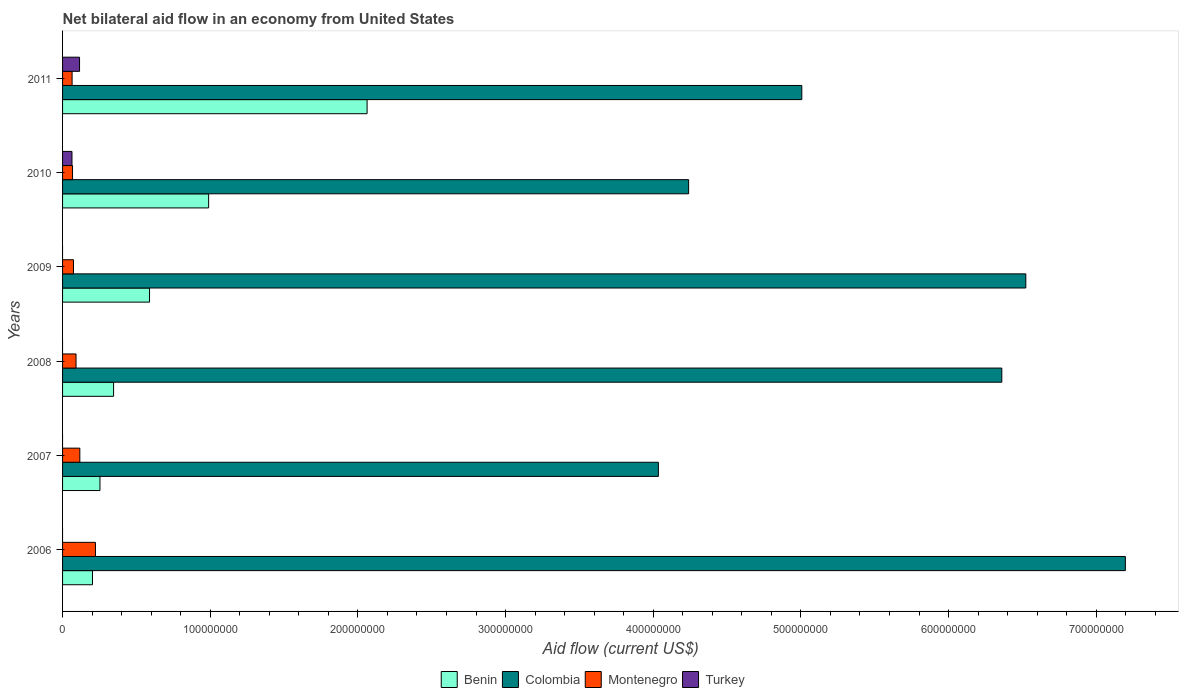How many different coloured bars are there?
Your answer should be very brief. 4. How many groups of bars are there?
Offer a terse response. 6. Are the number of bars on each tick of the Y-axis equal?
Your answer should be compact. No. How many bars are there on the 5th tick from the top?
Make the answer very short. 3. How many bars are there on the 4th tick from the bottom?
Ensure brevity in your answer.  3. What is the net bilateral aid flow in Montenegro in 2009?
Your answer should be compact. 7.38e+06. Across all years, what is the maximum net bilateral aid flow in Colombia?
Keep it short and to the point. 7.20e+08. Across all years, what is the minimum net bilateral aid flow in Turkey?
Your answer should be compact. 0. In which year was the net bilateral aid flow in Turkey maximum?
Your answer should be compact. 2011. What is the total net bilateral aid flow in Benin in the graph?
Your response must be concise. 4.44e+08. What is the difference between the net bilateral aid flow in Montenegro in 2009 and that in 2010?
Offer a very short reply. 6.30e+05. What is the difference between the net bilateral aid flow in Benin in 2009 and the net bilateral aid flow in Colombia in 2011?
Ensure brevity in your answer.  -4.42e+08. What is the average net bilateral aid flow in Turkey per year?
Ensure brevity in your answer.  2.98e+06. In the year 2008, what is the difference between the net bilateral aid flow in Benin and net bilateral aid flow in Colombia?
Your answer should be very brief. -6.02e+08. What is the ratio of the net bilateral aid flow in Montenegro in 2007 to that in 2010?
Make the answer very short. 1.73. What is the difference between the highest and the second highest net bilateral aid flow in Colombia?
Your answer should be very brief. 6.74e+07. What is the difference between the highest and the lowest net bilateral aid flow in Turkey?
Offer a terse response. 1.15e+07. How many bars are there?
Your response must be concise. 20. How many years are there in the graph?
Keep it short and to the point. 6. What is the difference between two consecutive major ticks on the X-axis?
Offer a very short reply. 1.00e+08. Does the graph contain any zero values?
Your answer should be compact. Yes. Where does the legend appear in the graph?
Offer a terse response. Bottom center. How many legend labels are there?
Keep it short and to the point. 4. What is the title of the graph?
Provide a short and direct response. Net bilateral aid flow in an economy from United States. Does "Sri Lanka" appear as one of the legend labels in the graph?
Make the answer very short. No. What is the label or title of the Y-axis?
Your response must be concise. Years. What is the Aid flow (current US$) of Benin in 2006?
Ensure brevity in your answer.  2.03e+07. What is the Aid flow (current US$) of Colombia in 2006?
Ensure brevity in your answer.  7.20e+08. What is the Aid flow (current US$) in Montenegro in 2006?
Offer a very short reply. 2.23e+07. What is the Aid flow (current US$) of Benin in 2007?
Ensure brevity in your answer.  2.53e+07. What is the Aid flow (current US$) of Colombia in 2007?
Your answer should be compact. 4.04e+08. What is the Aid flow (current US$) in Montenegro in 2007?
Ensure brevity in your answer.  1.17e+07. What is the Aid flow (current US$) in Turkey in 2007?
Your response must be concise. 0. What is the Aid flow (current US$) of Benin in 2008?
Ensure brevity in your answer.  3.46e+07. What is the Aid flow (current US$) of Colombia in 2008?
Offer a very short reply. 6.36e+08. What is the Aid flow (current US$) in Montenegro in 2008?
Your response must be concise. 9.12e+06. What is the Aid flow (current US$) of Turkey in 2008?
Give a very brief answer. 0. What is the Aid flow (current US$) in Benin in 2009?
Ensure brevity in your answer.  5.89e+07. What is the Aid flow (current US$) in Colombia in 2009?
Your answer should be very brief. 6.52e+08. What is the Aid flow (current US$) of Montenegro in 2009?
Offer a terse response. 7.38e+06. What is the Aid flow (current US$) of Benin in 2010?
Keep it short and to the point. 9.89e+07. What is the Aid flow (current US$) of Colombia in 2010?
Ensure brevity in your answer.  4.24e+08. What is the Aid flow (current US$) in Montenegro in 2010?
Provide a succinct answer. 6.75e+06. What is the Aid flow (current US$) of Turkey in 2010?
Offer a very short reply. 6.38e+06. What is the Aid flow (current US$) in Benin in 2011?
Provide a short and direct response. 2.06e+08. What is the Aid flow (current US$) in Colombia in 2011?
Offer a very short reply. 5.01e+08. What is the Aid flow (current US$) of Montenegro in 2011?
Make the answer very short. 6.45e+06. What is the Aid flow (current US$) of Turkey in 2011?
Offer a terse response. 1.15e+07. Across all years, what is the maximum Aid flow (current US$) in Benin?
Provide a short and direct response. 2.06e+08. Across all years, what is the maximum Aid flow (current US$) of Colombia?
Provide a short and direct response. 7.20e+08. Across all years, what is the maximum Aid flow (current US$) in Montenegro?
Your response must be concise. 2.23e+07. Across all years, what is the maximum Aid flow (current US$) in Turkey?
Your answer should be compact. 1.15e+07. Across all years, what is the minimum Aid flow (current US$) in Benin?
Provide a short and direct response. 2.03e+07. Across all years, what is the minimum Aid flow (current US$) of Colombia?
Your answer should be very brief. 4.04e+08. Across all years, what is the minimum Aid flow (current US$) in Montenegro?
Keep it short and to the point. 6.45e+06. Across all years, what is the minimum Aid flow (current US$) of Turkey?
Give a very brief answer. 0. What is the total Aid flow (current US$) in Benin in the graph?
Give a very brief answer. 4.44e+08. What is the total Aid flow (current US$) of Colombia in the graph?
Provide a succinct answer. 3.34e+09. What is the total Aid flow (current US$) in Montenegro in the graph?
Provide a succinct answer. 6.37e+07. What is the total Aid flow (current US$) in Turkey in the graph?
Ensure brevity in your answer.  1.79e+07. What is the difference between the Aid flow (current US$) of Benin in 2006 and that in 2007?
Give a very brief answer. -5.06e+06. What is the difference between the Aid flow (current US$) in Colombia in 2006 and that in 2007?
Offer a very short reply. 3.16e+08. What is the difference between the Aid flow (current US$) of Montenegro in 2006 and that in 2007?
Your answer should be very brief. 1.06e+07. What is the difference between the Aid flow (current US$) of Benin in 2006 and that in 2008?
Provide a succinct answer. -1.43e+07. What is the difference between the Aid flow (current US$) of Colombia in 2006 and that in 2008?
Offer a very short reply. 8.37e+07. What is the difference between the Aid flow (current US$) of Montenegro in 2006 and that in 2008?
Give a very brief answer. 1.32e+07. What is the difference between the Aid flow (current US$) in Benin in 2006 and that in 2009?
Provide a succinct answer. -3.86e+07. What is the difference between the Aid flow (current US$) in Colombia in 2006 and that in 2009?
Your answer should be compact. 6.74e+07. What is the difference between the Aid flow (current US$) in Montenegro in 2006 and that in 2009?
Ensure brevity in your answer.  1.49e+07. What is the difference between the Aid flow (current US$) of Benin in 2006 and that in 2010?
Offer a very short reply. -7.87e+07. What is the difference between the Aid flow (current US$) in Colombia in 2006 and that in 2010?
Your response must be concise. 2.96e+08. What is the difference between the Aid flow (current US$) of Montenegro in 2006 and that in 2010?
Make the answer very short. 1.55e+07. What is the difference between the Aid flow (current US$) in Benin in 2006 and that in 2011?
Ensure brevity in your answer.  -1.86e+08. What is the difference between the Aid flow (current US$) of Colombia in 2006 and that in 2011?
Your answer should be compact. 2.19e+08. What is the difference between the Aid flow (current US$) in Montenegro in 2006 and that in 2011?
Keep it short and to the point. 1.58e+07. What is the difference between the Aid flow (current US$) of Benin in 2007 and that in 2008?
Your response must be concise. -9.23e+06. What is the difference between the Aid flow (current US$) in Colombia in 2007 and that in 2008?
Provide a succinct answer. -2.33e+08. What is the difference between the Aid flow (current US$) of Montenegro in 2007 and that in 2008?
Your answer should be very brief. 2.57e+06. What is the difference between the Aid flow (current US$) of Benin in 2007 and that in 2009?
Provide a succinct answer. -3.36e+07. What is the difference between the Aid flow (current US$) of Colombia in 2007 and that in 2009?
Your answer should be compact. -2.49e+08. What is the difference between the Aid flow (current US$) of Montenegro in 2007 and that in 2009?
Offer a terse response. 4.31e+06. What is the difference between the Aid flow (current US$) in Benin in 2007 and that in 2010?
Your answer should be very brief. -7.36e+07. What is the difference between the Aid flow (current US$) in Colombia in 2007 and that in 2010?
Your response must be concise. -2.05e+07. What is the difference between the Aid flow (current US$) in Montenegro in 2007 and that in 2010?
Your answer should be very brief. 4.94e+06. What is the difference between the Aid flow (current US$) in Benin in 2007 and that in 2011?
Your answer should be very brief. -1.81e+08. What is the difference between the Aid flow (current US$) of Colombia in 2007 and that in 2011?
Your response must be concise. -9.71e+07. What is the difference between the Aid flow (current US$) in Montenegro in 2007 and that in 2011?
Offer a terse response. 5.24e+06. What is the difference between the Aid flow (current US$) in Benin in 2008 and that in 2009?
Offer a terse response. -2.43e+07. What is the difference between the Aid flow (current US$) of Colombia in 2008 and that in 2009?
Offer a terse response. -1.62e+07. What is the difference between the Aid flow (current US$) in Montenegro in 2008 and that in 2009?
Provide a short and direct response. 1.74e+06. What is the difference between the Aid flow (current US$) in Benin in 2008 and that in 2010?
Ensure brevity in your answer.  -6.44e+07. What is the difference between the Aid flow (current US$) of Colombia in 2008 and that in 2010?
Your response must be concise. 2.12e+08. What is the difference between the Aid flow (current US$) in Montenegro in 2008 and that in 2010?
Your answer should be compact. 2.37e+06. What is the difference between the Aid flow (current US$) in Benin in 2008 and that in 2011?
Keep it short and to the point. -1.72e+08. What is the difference between the Aid flow (current US$) in Colombia in 2008 and that in 2011?
Provide a short and direct response. 1.35e+08. What is the difference between the Aid flow (current US$) of Montenegro in 2008 and that in 2011?
Ensure brevity in your answer.  2.67e+06. What is the difference between the Aid flow (current US$) of Benin in 2009 and that in 2010?
Keep it short and to the point. -4.00e+07. What is the difference between the Aid flow (current US$) of Colombia in 2009 and that in 2010?
Offer a very short reply. 2.28e+08. What is the difference between the Aid flow (current US$) in Montenegro in 2009 and that in 2010?
Offer a very short reply. 6.30e+05. What is the difference between the Aid flow (current US$) of Benin in 2009 and that in 2011?
Offer a terse response. -1.47e+08. What is the difference between the Aid flow (current US$) in Colombia in 2009 and that in 2011?
Keep it short and to the point. 1.52e+08. What is the difference between the Aid flow (current US$) of Montenegro in 2009 and that in 2011?
Offer a terse response. 9.30e+05. What is the difference between the Aid flow (current US$) of Benin in 2010 and that in 2011?
Provide a succinct answer. -1.07e+08. What is the difference between the Aid flow (current US$) of Colombia in 2010 and that in 2011?
Your answer should be compact. -7.67e+07. What is the difference between the Aid flow (current US$) in Montenegro in 2010 and that in 2011?
Provide a succinct answer. 3.00e+05. What is the difference between the Aid flow (current US$) of Turkey in 2010 and that in 2011?
Provide a short and direct response. -5.12e+06. What is the difference between the Aid flow (current US$) of Benin in 2006 and the Aid flow (current US$) of Colombia in 2007?
Make the answer very short. -3.83e+08. What is the difference between the Aid flow (current US$) in Benin in 2006 and the Aid flow (current US$) in Montenegro in 2007?
Give a very brief answer. 8.58e+06. What is the difference between the Aid flow (current US$) in Colombia in 2006 and the Aid flow (current US$) in Montenegro in 2007?
Make the answer very short. 7.08e+08. What is the difference between the Aid flow (current US$) of Benin in 2006 and the Aid flow (current US$) of Colombia in 2008?
Your answer should be compact. -6.16e+08. What is the difference between the Aid flow (current US$) in Benin in 2006 and the Aid flow (current US$) in Montenegro in 2008?
Provide a short and direct response. 1.12e+07. What is the difference between the Aid flow (current US$) of Colombia in 2006 and the Aid flow (current US$) of Montenegro in 2008?
Provide a succinct answer. 7.11e+08. What is the difference between the Aid flow (current US$) of Benin in 2006 and the Aid flow (current US$) of Colombia in 2009?
Your answer should be very brief. -6.32e+08. What is the difference between the Aid flow (current US$) of Benin in 2006 and the Aid flow (current US$) of Montenegro in 2009?
Your response must be concise. 1.29e+07. What is the difference between the Aid flow (current US$) in Colombia in 2006 and the Aid flow (current US$) in Montenegro in 2009?
Your answer should be compact. 7.12e+08. What is the difference between the Aid flow (current US$) of Benin in 2006 and the Aid flow (current US$) of Colombia in 2010?
Offer a very short reply. -4.04e+08. What is the difference between the Aid flow (current US$) in Benin in 2006 and the Aid flow (current US$) in Montenegro in 2010?
Ensure brevity in your answer.  1.35e+07. What is the difference between the Aid flow (current US$) in Benin in 2006 and the Aid flow (current US$) in Turkey in 2010?
Offer a very short reply. 1.39e+07. What is the difference between the Aid flow (current US$) of Colombia in 2006 and the Aid flow (current US$) of Montenegro in 2010?
Make the answer very short. 7.13e+08. What is the difference between the Aid flow (current US$) in Colombia in 2006 and the Aid flow (current US$) in Turkey in 2010?
Offer a terse response. 7.13e+08. What is the difference between the Aid flow (current US$) of Montenegro in 2006 and the Aid flow (current US$) of Turkey in 2010?
Your answer should be very brief. 1.59e+07. What is the difference between the Aid flow (current US$) in Benin in 2006 and the Aid flow (current US$) in Colombia in 2011?
Offer a very short reply. -4.80e+08. What is the difference between the Aid flow (current US$) of Benin in 2006 and the Aid flow (current US$) of Montenegro in 2011?
Provide a short and direct response. 1.38e+07. What is the difference between the Aid flow (current US$) in Benin in 2006 and the Aid flow (current US$) in Turkey in 2011?
Your answer should be compact. 8.77e+06. What is the difference between the Aid flow (current US$) of Colombia in 2006 and the Aid flow (current US$) of Montenegro in 2011?
Your answer should be very brief. 7.13e+08. What is the difference between the Aid flow (current US$) in Colombia in 2006 and the Aid flow (current US$) in Turkey in 2011?
Offer a terse response. 7.08e+08. What is the difference between the Aid flow (current US$) in Montenegro in 2006 and the Aid flow (current US$) in Turkey in 2011?
Your answer should be very brief. 1.08e+07. What is the difference between the Aid flow (current US$) of Benin in 2007 and the Aid flow (current US$) of Colombia in 2008?
Provide a short and direct response. -6.11e+08. What is the difference between the Aid flow (current US$) in Benin in 2007 and the Aid flow (current US$) in Montenegro in 2008?
Keep it short and to the point. 1.62e+07. What is the difference between the Aid flow (current US$) of Colombia in 2007 and the Aid flow (current US$) of Montenegro in 2008?
Provide a short and direct response. 3.94e+08. What is the difference between the Aid flow (current US$) of Benin in 2007 and the Aid flow (current US$) of Colombia in 2009?
Make the answer very short. -6.27e+08. What is the difference between the Aid flow (current US$) of Benin in 2007 and the Aid flow (current US$) of Montenegro in 2009?
Your answer should be very brief. 1.80e+07. What is the difference between the Aid flow (current US$) of Colombia in 2007 and the Aid flow (current US$) of Montenegro in 2009?
Keep it short and to the point. 3.96e+08. What is the difference between the Aid flow (current US$) of Benin in 2007 and the Aid flow (current US$) of Colombia in 2010?
Your answer should be very brief. -3.99e+08. What is the difference between the Aid flow (current US$) of Benin in 2007 and the Aid flow (current US$) of Montenegro in 2010?
Your response must be concise. 1.86e+07. What is the difference between the Aid flow (current US$) of Benin in 2007 and the Aid flow (current US$) of Turkey in 2010?
Offer a very short reply. 1.90e+07. What is the difference between the Aid flow (current US$) in Colombia in 2007 and the Aid flow (current US$) in Montenegro in 2010?
Ensure brevity in your answer.  3.97e+08. What is the difference between the Aid flow (current US$) of Colombia in 2007 and the Aid flow (current US$) of Turkey in 2010?
Make the answer very short. 3.97e+08. What is the difference between the Aid flow (current US$) of Montenegro in 2007 and the Aid flow (current US$) of Turkey in 2010?
Provide a short and direct response. 5.31e+06. What is the difference between the Aid flow (current US$) of Benin in 2007 and the Aid flow (current US$) of Colombia in 2011?
Offer a terse response. -4.75e+08. What is the difference between the Aid flow (current US$) in Benin in 2007 and the Aid flow (current US$) in Montenegro in 2011?
Ensure brevity in your answer.  1.89e+07. What is the difference between the Aid flow (current US$) of Benin in 2007 and the Aid flow (current US$) of Turkey in 2011?
Offer a very short reply. 1.38e+07. What is the difference between the Aid flow (current US$) in Colombia in 2007 and the Aid flow (current US$) in Montenegro in 2011?
Provide a short and direct response. 3.97e+08. What is the difference between the Aid flow (current US$) of Colombia in 2007 and the Aid flow (current US$) of Turkey in 2011?
Your answer should be very brief. 3.92e+08. What is the difference between the Aid flow (current US$) in Benin in 2008 and the Aid flow (current US$) in Colombia in 2009?
Ensure brevity in your answer.  -6.18e+08. What is the difference between the Aid flow (current US$) of Benin in 2008 and the Aid flow (current US$) of Montenegro in 2009?
Provide a succinct answer. 2.72e+07. What is the difference between the Aid flow (current US$) of Colombia in 2008 and the Aid flow (current US$) of Montenegro in 2009?
Provide a short and direct response. 6.29e+08. What is the difference between the Aid flow (current US$) of Benin in 2008 and the Aid flow (current US$) of Colombia in 2010?
Your response must be concise. -3.89e+08. What is the difference between the Aid flow (current US$) of Benin in 2008 and the Aid flow (current US$) of Montenegro in 2010?
Provide a short and direct response. 2.78e+07. What is the difference between the Aid flow (current US$) of Benin in 2008 and the Aid flow (current US$) of Turkey in 2010?
Keep it short and to the point. 2.82e+07. What is the difference between the Aid flow (current US$) in Colombia in 2008 and the Aid flow (current US$) in Montenegro in 2010?
Offer a very short reply. 6.29e+08. What is the difference between the Aid flow (current US$) in Colombia in 2008 and the Aid flow (current US$) in Turkey in 2010?
Offer a terse response. 6.30e+08. What is the difference between the Aid flow (current US$) in Montenegro in 2008 and the Aid flow (current US$) in Turkey in 2010?
Your answer should be very brief. 2.74e+06. What is the difference between the Aid flow (current US$) in Benin in 2008 and the Aid flow (current US$) in Colombia in 2011?
Your response must be concise. -4.66e+08. What is the difference between the Aid flow (current US$) in Benin in 2008 and the Aid flow (current US$) in Montenegro in 2011?
Your answer should be very brief. 2.81e+07. What is the difference between the Aid flow (current US$) in Benin in 2008 and the Aid flow (current US$) in Turkey in 2011?
Give a very brief answer. 2.31e+07. What is the difference between the Aid flow (current US$) of Colombia in 2008 and the Aid flow (current US$) of Montenegro in 2011?
Offer a terse response. 6.30e+08. What is the difference between the Aid flow (current US$) in Colombia in 2008 and the Aid flow (current US$) in Turkey in 2011?
Keep it short and to the point. 6.25e+08. What is the difference between the Aid flow (current US$) in Montenegro in 2008 and the Aid flow (current US$) in Turkey in 2011?
Your answer should be compact. -2.38e+06. What is the difference between the Aid flow (current US$) of Benin in 2009 and the Aid flow (current US$) of Colombia in 2010?
Make the answer very short. -3.65e+08. What is the difference between the Aid flow (current US$) in Benin in 2009 and the Aid flow (current US$) in Montenegro in 2010?
Your answer should be compact. 5.22e+07. What is the difference between the Aid flow (current US$) of Benin in 2009 and the Aid flow (current US$) of Turkey in 2010?
Offer a terse response. 5.25e+07. What is the difference between the Aid flow (current US$) of Colombia in 2009 and the Aid flow (current US$) of Montenegro in 2010?
Ensure brevity in your answer.  6.46e+08. What is the difference between the Aid flow (current US$) of Colombia in 2009 and the Aid flow (current US$) of Turkey in 2010?
Offer a terse response. 6.46e+08. What is the difference between the Aid flow (current US$) in Montenegro in 2009 and the Aid flow (current US$) in Turkey in 2010?
Offer a very short reply. 1.00e+06. What is the difference between the Aid flow (current US$) of Benin in 2009 and the Aid flow (current US$) of Colombia in 2011?
Ensure brevity in your answer.  -4.42e+08. What is the difference between the Aid flow (current US$) of Benin in 2009 and the Aid flow (current US$) of Montenegro in 2011?
Offer a very short reply. 5.24e+07. What is the difference between the Aid flow (current US$) in Benin in 2009 and the Aid flow (current US$) in Turkey in 2011?
Give a very brief answer. 4.74e+07. What is the difference between the Aid flow (current US$) in Colombia in 2009 and the Aid flow (current US$) in Montenegro in 2011?
Offer a very short reply. 6.46e+08. What is the difference between the Aid flow (current US$) of Colombia in 2009 and the Aid flow (current US$) of Turkey in 2011?
Your answer should be very brief. 6.41e+08. What is the difference between the Aid flow (current US$) in Montenegro in 2009 and the Aid flow (current US$) in Turkey in 2011?
Offer a very short reply. -4.12e+06. What is the difference between the Aid flow (current US$) in Benin in 2010 and the Aid flow (current US$) in Colombia in 2011?
Provide a succinct answer. -4.02e+08. What is the difference between the Aid flow (current US$) in Benin in 2010 and the Aid flow (current US$) in Montenegro in 2011?
Offer a very short reply. 9.25e+07. What is the difference between the Aid flow (current US$) in Benin in 2010 and the Aid flow (current US$) in Turkey in 2011?
Ensure brevity in your answer.  8.74e+07. What is the difference between the Aid flow (current US$) of Colombia in 2010 and the Aid flow (current US$) of Montenegro in 2011?
Ensure brevity in your answer.  4.18e+08. What is the difference between the Aid flow (current US$) of Colombia in 2010 and the Aid flow (current US$) of Turkey in 2011?
Provide a short and direct response. 4.12e+08. What is the difference between the Aid flow (current US$) of Montenegro in 2010 and the Aid flow (current US$) of Turkey in 2011?
Keep it short and to the point. -4.75e+06. What is the average Aid flow (current US$) in Benin per year?
Your answer should be very brief. 7.40e+07. What is the average Aid flow (current US$) of Colombia per year?
Make the answer very short. 5.56e+08. What is the average Aid flow (current US$) of Montenegro per year?
Give a very brief answer. 1.06e+07. What is the average Aid flow (current US$) in Turkey per year?
Keep it short and to the point. 2.98e+06. In the year 2006, what is the difference between the Aid flow (current US$) in Benin and Aid flow (current US$) in Colombia?
Provide a succinct answer. -6.99e+08. In the year 2006, what is the difference between the Aid flow (current US$) of Colombia and Aid flow (current US$) of Montenegro?
Offer a very short reply. 6.97e+08. In the year 2007, what is the difference between the Aid flow (current US$) of Benin and Aid flow (current US$) of Colombia?
Make the answer very short. -3.78e+08. In the year 2007, what is the difference between the Aid flow (current US$) of Benin and Aid flow (current US$) of Montenegro?
Your answer should be compact. 1.36e+07. In the year 2007, what is the difference between the Aid flow (current US$) of Colombia and Aid flow (current US$) of Montenegro?
Provide a short and direct response. 3.92e+08. In the year 2008, what is the difference between the Aid flow (current US$) of Benin and Aid flow (current US$) of Colombia?
Your answer should be compact. -6.02e+08. In the year 2008, what is the difference between the Aid flow (current US$) of Benin and Aid flow (current US$) of Montenegro?
Provide a short and direct response. 2.54e+07. In the year 2008, what is the difference between the Aid flow (current US$) of Colombia and Aid flow (current US$) of Montenegro?
Provide a short and direct response. 6.27e+08. In the year 2009, what is the difference between the Aid flow (current US$) in Benin and Aid flow (current US$) in Colombia?
Provide a short and direct response. -5.93e+08. In the year 2009, what is the difference between the Aid flow (current US$) in Benin and Aid flow (current US$) in Montenegro?
Ensure brevity in your answer.  5.15e+07. In the year 2009, what is the difference between the Aid flow (current US$) in Colombia and Aid flow (current US$) in Montenegro?
Offer a terse response. 6.45e+08. In the year 2010, what is the difference between the Aid flow (current US$) of Benin and Aid flow (current US$) of Colombia?
Your response must be concise. -3.25e+08. In the year 2010, what is the difference between the Aid flow (current US$) in Benin and Aid flow (current US$) in Montenegro?
Your answer should be very brief. 9.22e+07. In the year 2010, what is the difference between the Aid flow (current US$) of Benin and Aid flow (current US$) of Turkey?
Keep it short and to the point. 9.26e+07. In the year 2010, what is the difference between the Aid flow (current US$) in Colombia and Aid flow (current US$) in Montenegro?
Provide a short and direct response. 4.17e+08. In the year 2010, what is the difference between the Aid flow (current US$) in Colombia and Aid flow (current US$) in Turkey?
Provide a short and direct response. 4.18e+08. In the year 2010, what is the difference between the Aid flow (current US$) in Montenegro and Aid flow (current US$) in Turkey?
Offer a terse response. 3.70e+05. In the year 2011, what is the difference between the Aid flow (current US$) of Benin and Aid flow (current US$) of Colombia?
Provide a succinct answer. -2.94e+08. In the year 2011, what is the difference between the Aid flow (current US$) in Benin and Aid flow (current US$) in Montenegro?
Offer a terse response. 2.00e+08. In the year 2011, what is the difference between the Aid flow (current US$) of Benin and Aid flow (current US$) of Turkey?
Your answer should be very brief. 1.95e+08. In the year 2011, what is the difference between the Aid flow (current US$) in Colombia and Aid flow (current US$) in Montenegro?
Your response must be concise. 4.94e+08. In the year 2011, what is the difference between the Aid flow (current US$) of Colombia and Aid flow (current US$) of Turkey?
Make the answer very short. 4.89e+08. In the year 2011, what is the difference between the Aid flow (current US$) of Montenegro and Aid flow (current US$) of Turkey?
Your answer should be very brief. -5.05e+06. What is the ratio of the Aid flow (current US$) of Benin in 2006 to that in 2007?
Offer a terse response. 0.8. What is the ratio of the Aid flow (current US$) in Colombia in 2006 to that in 2007?
Provide a succinct answer. 1.78. What is the ratio of the Aid flow (current US$) in Montenegro in 2006 to that in 2007?
Make the answer very short. 1.91. What is the ratio of the Aid flow (current US$) in Benin in 2006 to that in 2008?
Your answer should be compact. 0.59. What is the ratio of the Aid flow (current US$) of Colombia in 2006 to that in 2008?
Offer a very short reply. 1.13. What is the ratio of the Aid flow (current US$) of Montenegro in 2006 to that in 2008?
Your response must be concise. 2.44. What is the ratio of the Aid flow (current US$) in Benin in 2006 to that in 2009?
Ensure brevity in your answer.  0.34. What is the ratio of the Aid flow (current US$) in Colombia in 2006 to that in 2009?
Make the answer very short. 1.1. What is the ratio of the Aid flow (current US$) in Montenegro in 2006 to that in 2009?
Provide a succinct answer. 3.02. What is the ratio of the Aid flow (current US$) in Benin in 2006 to that in 2010?
Make the answer very short. 0.2. What is the ratio of the Aid flow (current US$) of Colombia in 2006 to that in 2010?
Your response must be concise. 1.7. What is the ratio of the Aid flow (current US$) of Montenegro in 2006 to that in 2010?
Your answer should be very brief. 3.3. What is the ratio of the Aid flow (current US$) in Benin in 2006 to that in 2011?
Offer a very short reply. 0.1. What is the ratio of the Aid flow (current US$) of Colombia in 2006 to that in 2011?
Keep it short and to the point. 1.44. What is the ratio of the Aid flow (current US$) in Montenegro in 2006 to that in 2011?
Ensure brevity in your answer.  3.45. What is the ratio of the Aid flow (current US$) of Benin in 2007 to that in 2008?
Offer a terse response. 0.73. What is the ratio of the Aid flow (current US$) in Colombia in 2007 to that in 2008?
Make the answer very short. 0.63. What is the ratio of the Aid flow (current US$) of Montenegro in 2007 to that in 2008?
Keep it short and to the point. 1.28. What is the ratio of the Aid flow (current US$) in Benin in 2007 to that in 2009?
Ensure brevity in your answer.  0.43. What is the ratio of the Aid flow (current US$) in Colombia in 2007 to that in 2009?
Offer a terse response. 0.62. What is the ratio of the Aid flow (current US$) in Montenegro in 2007 to that in 2009?
Offer a terse response. 1.58. What is the ratio of the Aid flow (current US$) in Benin in 2007 to that in 2010?
Ensure brevity in your answer.  0.26. What is the ratio of the Aid flow (current US$) of Colombia in 2007 to that in 2010?
Offer a very short reply. 0.95. What is the ratio of the Aid flow (current US$) in Montenegro in 2007 to that in 2010?
Offer a terse response. 1.73. What is the ratio of the Aid flow (current US$) in Benin in 2007 to that in 2011?
Keep it short and to the point. 0.12. What is the ratio of the Aid flow (current US$) in Colombia in 2007 to that in 2011?
Your answer should be compact. 0.81. What is the ratio of the Aid flow (current US$) in Montenegro in 2007 to that in 2011?
Provide a short and direct response. 1.81. What is the ratio of the Aid flow (current US$) in Benin in 2008 to that in 2009?
Your answer should be very brief. 0.59. What is the ratio of the Aid flow (current US$) in Colombia in 2008 to that in 2009?
Provide a short and direct response. 0.98. What is the ratio of the Aid flow (current US$) in Montenegro in 2008 to that in 2009?
Provide a short and direct response. 1.24. What is the ratio of the Aid flow (current US$) of Benin in 2008 to that in 2010?
Your answer should be compact. 0.35. What is the ratio of the Aid flow (current US$) in Colombia in 2008 to that in 2010?
Your answer should be very brief. 1.5. What is the ratio of the Aid flow (current US$) of Montenegro in 2008 to that in 2010?
Make the answer very short. 1.35. What is the ratio of the Aid flow (current US$) in Benin in 2008 to that in 2011?
Your answer should be compact. 0.17. What is the ratio of the Aid flow (current US$) in Colombia in 2008 to that in 2011?
Ensure brevity in your answer.  1.27. What is the ratio of the Aid flow (current US$) of Montenegro in 2008 to that in 2011?
Keep it short and to the point. 1.41. What is the ratio of the Aid flow (current US$) in Benin in 2009 to that in 2010?
Keep it short and to the point. 0.6. What is the ratio of the Aid flow (current US$) in Colombia in 2009 to that in 2010?
Keep it short and to the point. 1.54. What is the ratio of the Aid flow (current US$) of Montenegro in 2009 to that in 2010?
Keep it short and to the point. 1.09. What is the ratio of the Aid flow (current US$) of Benin in 2009 to that in 2011?
Give a very brief answer. 0.29. What is the ratio of the Aid flow (current US$) of Colombia in 2009 to that in 2011?
Give a very brief answer. 1.3. What is the ratio of the Aid flow (current US$) in Montenegro in 2009 to that in 2011?
Ensure brevity in your answer.  1.14. What is the ratio of the Aid flow (current US$) of Benin in 2010 to that in 2011?
Offer a terse response. 0.48. What is the ratio of the Aid flow (current US$) in Colombia in 2010 to that in 2011?
Keep it short and to the point. 0.85. What is the ratio of the Aid flow (current US$) in Montenegro in 2010 to that in 2011?
Keep it short and to the point. 1.05. What is the ratio of the Aid flow (current US$) in Turkey in 2010 to that in 2011?
Your response must be concise. 0.55. What is the difference between the highest and the second highest Aid flow (current US$) of Benin?
Your answer should be compact. 1.07e+08. What is the difference between the highest and the second highest Aid flow (current US$) of Colombia?
Keep it short and to the point. 6.74e+07. What is the difference between the highest and the second highest Aid flow (current US$) of Montenegro?
Make the answer very short. 1.06e+07. What is the difference between the highest and the lowest Aid flow (current US$) of Benin?
Ensure brevity in your answer.  1.86e+08. What is the difference between the highest and the lowest Aid flow (current US$) in Colombia?
Give a very brief answer. 3.16e+08. What is the difference between the highest and the lowest Aid flow (current US$) in Montenegro?
Your answer should be compact. 1.58e+07. What is the difference between the highest and the lowest Aid flow (current US$) in Turkey?
Your response must be concise. 1.15e+07. 